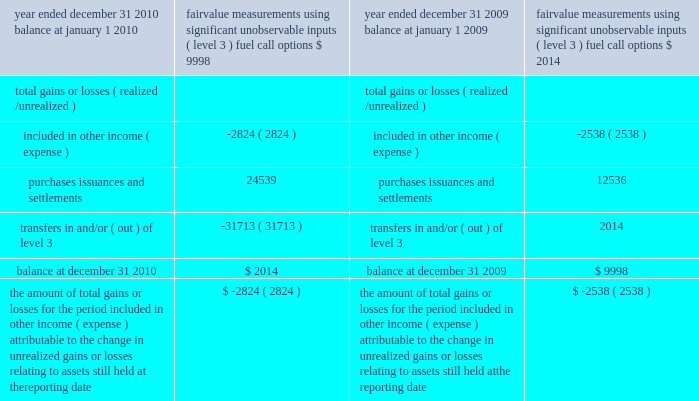Notes to the consolidated financial statements non-financial assets and liabilities measured at fair value on a non-recurring basis during 2009 , we classified the atlantic star as held for sale and recognized a charge of $ 7.1 million to reduce the carrying value of the ship to its fair value less cost to sell based on a firm offer received during 2009 .
This amount was recorded within other operating expenses in our consolidated statement of operations .
We determined the fair market value of the atlantic star as of december 31 , 2010 based on comparable ship sales adjusted for the condition , age and size of the ship .
We have categorized these inputs as level 3 because they are largely based on our own assump- tions .
As of december 31 , 2010 , the carrying amount of the atlantic star which we still believe represents its fair value was $ 46.4 million .
The table presents a reconciliation of the company 2019s fuel call options 2019 beginning and ending balances as follows ( in thousands ) : fair value fair value measurements measurements using significant using significant unobservable unobservable year ended december 31 , 2010 inputs ( level 3 ) year ended december 31 , 2009 inputs ( level 3 ) fuel call options fuel call options balance at january 1 , 2010 $ 9998 balance at january 1 , 2009 $ 2007 2007 2007 2007 2014 total gains or losses ( realized/ unrealized ) total gains or losses ( realized/ unrealized ) .
The amount of total gains or losses for the period included in other income ( expense ) attributable to the change in unrealized gains or losses relating to assets still held at the reporting date $ ( 2824 ) the amount of total gains or losses for the period included in other income ( expense ) attributable to the change in unrealized gains or losses relating to assets still held at the reporting date $ ( 2538 ) during the fourth quarter of 2010 , we changed our valuation technique for fuel call options to a market approach method which employs inputs that are observable .
The fair value for fuel call options is determined by using the prevailing market price for the instruments consisting of published price quotes for similar assets based on recent transactions in an active market .
We believe that level 2 categorization is appropriate due to an increase in the observability and transparency of significant inputs .
Previously , we derived the fair value of our fuel call options using standard option pricing models with inputs based on the options 2019 contract terms and data either readily available or formulated from public market informa- tion .
The fuel call options were categorized as level 3 because certain inputs , principally volatility , were unobservable .
Net transfers in and/or out of level 3 are reported as having occurred at the end of the quarter in which the transfer occurred ; therefore , gains or losses reflected in the table above for 2010 include fourth quarter fuel call option gains or losses .
The reported fair values are based on a variety of factors and assumptions .
Accordingly , the fair values may not represent actual values of the financial instru- ments and long-lived assets that could have been realized as of december 31 , 2010 or december 31 , 2009 , or that will be realized in the future and do not include expenses that could be incurred in an actual sale or settlement .
Derivative instruments we are exposed to market risk attributable to changes in interest rates , foreign currency exchange rates and fuel prices .
We manage these risks through a combi- nation of our normal operating and financing activities and through the use of derivative financial instruments pursuant to our hedging practices and policies .
The financial impact of these hedging instruments is pri- marily offset by corresponding changes in the under- lying exposures being hedged .
We achieve this by closely matching the amount , term and conditions of the derivative instrument with the underlying risk being hedged .
We do not hold or issue derivative financial instruments for trading or other speculative purposes .
We monitor our derivative positions using techniques including market valuations and sensitivity analyses. .
What percent did purchase issuances and settlements increase from year ended 2009 to year ended 2010? 
Computations: (((24539 - 12536) / 12536) * 100)
Answer: 95.74825. 